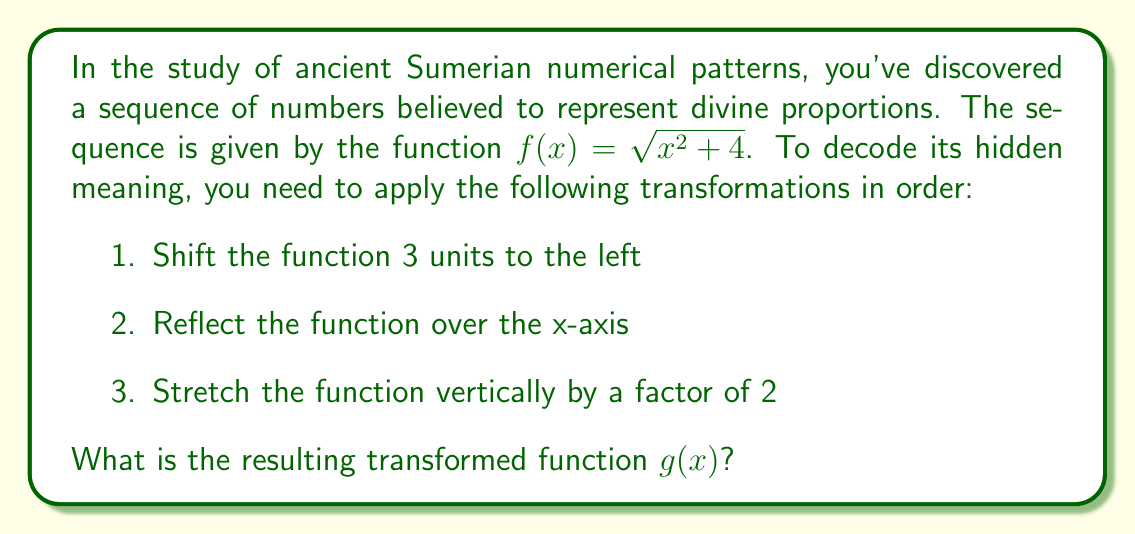Help me with this question. Let's apply the transformations step by step:

1. Shift 3 units to the left:
   $f_1(x) = \sqrt{(x+3)^2 + 4}$

2. Reflect over the x-axis:
   $f_2(x) = -\sqrt{(x+3)^2 + 4}$

3. Stretch vertically by a factor of 2:
   $g(x) = 2 \cdot (-\sqrt{(x+3)^2 + 4})$

Simplifying:
$g(x) = -2\sqrt{(x+3)^2 + 4}$

This is the final transformed function.
Answer: $g(x) = -2\sqrt{(x+3)^2 + 4}$ 